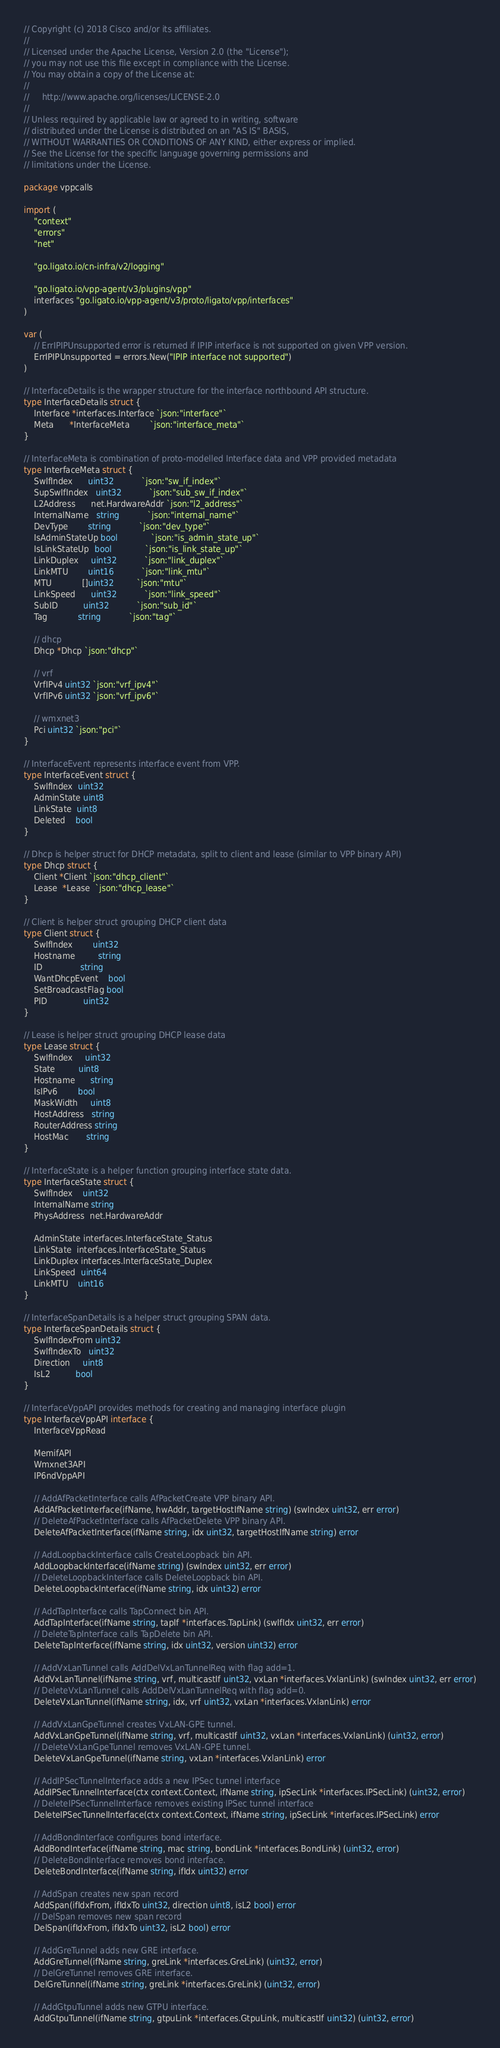<code> <loc_0><loc_0><loc_500><loc_500><_Go_>// Copyright (c) 2018 Cisco and/or its affiliates.
//
// Licensed under the Apache License, Version 2.0 (the "License");
// you may not use this file except in compliance with the License.
// You may obtain a copy of the License at:
//
//     http://www.apache.org/licenses/LICENSE-2.0
//
// Unless required by applicable law or agreed to in writing, software
// distributed under the License is distributed on an "AS IS" BASIS,
// WITHOUT WARRANTIES OR CONDITIONS OF ANY KIND, either express or implied.
// See the License for the specific language governing permissions and
// limitations under the License.

package vppcalls

import (
	"context"
	"errors"
	"net"

	"go.ligato.io/cn-infra/v2/logging"

	"go.ligato.io/vpp-agent/v3/plugins/vpp"
	interfaces "go.ligato.io/vpp-agent/v3/proto/ligato/vpp/interfaces"
)

var (
	// ErrIPIPUnsupported error is returned if IPIP interface is not supported on given VPP version.
	ErrIPIPUnsupported = errors.New("IPIP interface not supported")
)

// InterfaceDetails is the wrapper structure for the interface northbound API structure.
type InterfaceDetails struct {
	Interface *interfaces.Interface `json:"interface"`
	Meta      *InterfaceMeta        `json:"interface_meta"`
}

// InterfaceMeta is combination of proto-modelled Interface data and VPP provided metadata
type InterfaceMeta struct {
	SwIfIndex      uint32           `json:"sw_if_index"`
	SupSwIfIndex   uint32           `json:"sub_sw_if_index"`
	L2Address      net.HardwareAddr `json:"l2_address"`
	InternalName   string           `json:"internal_name"`
	DevType        string           `json:"dev_type"`
	IsAdminStateUp bool             `json:"is_admin_state_up"`
	IsLinkStateUp  bool             `json:"is_link_state_up"`
	LinkDuplex     uint32           `json:"link_duplex"`
	LinkMTU        uint16           `json:"link_mtu"`
	MTU            []uint32         `json:"mtu"`
	LinkSpeed      uint32           `json:"link_speed"`
	SubID          uint32           `json:"sub_id"`
	Tag            string           `json:"tag"`

	// dhcp
	Dhcp *Dhcp `json:"dhcp"`

	// vrf
	VrfIPv4 uint32 `json:"vrf_ipv4"`
	VrfIPv6 uint32 `json:"vrf_ipv6"`

	// wmxnet3
	Pci uint32 `json:"pci"`
}

// InterfaceEvent represents interface event from VPP.
type InterfaceEvent struct {
	SwIfIndex  uint32
	AdminState uint8
	LinkState  uint8
	Deleted    bool
}

// Dhcp is helper struct for DHCP metadata, split to client and lease (similar to VPP binary API)
type Dhcp struct {
	Client *Client `json:"dhcp_client"`
	Lease  *Lease  `json:"dhcp_lease"`
}

// Client is helper struct grouping DHCP client data
type Client struct {
	SwIfIndex        uint32
	Hostname         string
	ID               string
	WantDhcpEvent    bool
	SetBroadcastFlag bool
	PID              uint32
}

// Lease is helper struct grouping DHCP lease data
type Lease struct {
	SwIfIndex     uint32
	State         uint8
	Hostname      string
	IsIPv6        bool
	MaskWidth     uint8
	HostAddress   string
	RouterAddress string
	HostMac       string
}

// InterfaceState is a helper function grouping interface state data.
type InterfaceState struct {
	SwIfIndex    uint32
	InternalName string
	PhysAddress  net.HardwareAddr

	AdminState interfaces.InterfaceState_Status
	LinkState  interfaces.InterfaceState_Status
	LinkDuplex interfaces.InterfaceState_Duplex
	LinkSpeed  uint64
	LinkMTU    uint16
}

// InterfaceSpanDetails is a helper struct grouping SPAN data.
type InterfaceSpanDetails struct {
	SwIfIndexFrom uint32
	SwIfIndexTo   uint32
	Direction     uint8
	IsL2          bool
}

// InterfaceVppAPI provides methods for creating and managing interface plugin
type InterfaceVppAPI interface {
	InterfaceVppRead

	MemifAPI
	Wmxnet3API
	IP6ndVppAPI

	// AddAfPacketInterface calls AfPacketCreate VPP binary API.
	AddAfPacketInterface(ifName, hwAddr, targetHostIfName string) (swIndex uint32, err error)
	// DeleteAfPacketInterface calls AfPacketDelete VPP binary API.
	DeleteAfPacketInterface(ifName string, idx uint32, targetHostIfName string) error

	// AddLoopbackInterface calls CreateLoopback bin API.
	AddLoopbackInterface(ifName string) (swIndex uint32, err error)
	// DeleteLoopbackInterface calls DeleteLoopback bin API.
	DeleteLoopbackInterface(ifName string, idx uint32) error

	// AddTapInterface calls TapConnect bin API.
	AddTapInterface(ifName string, tapIf *interfaces.TapLink) (swIfIdx uint32, err error)
	// DeleteTapInterface calls TapDelete bin API.
	DeleteTapInterface(ifName string, idx uint32, version uint32) error

	// AddVxLanTunnel calls AddDelVxLanTunnelReq with flag add=1.
	AddVxLanTunnel(ifName string, vrf, multicastIf uint32, vxLan *interfaces.VxlanLink) (swIndex uint32, err error)
	// DeleteVxLanTunnel calls AddDelVxLanTunnelReq with flag add=0.
	DeleteVxLanTunnel(ifName string, idx, vrf uint32, vxLan *interfaces.VxlanLink) error

	// AddVxLanGpeTunnel creates VxLAN-GPE tunnel.
	AddVxLanGpeTunnel(ifName string, vrf, multicastIf uint32, vxLan *interfaces.VxlanLink) (uint32, error)
	// DeleteVxLanGpeTunnel removes VxLAN-GPE tunnel.
	DeleteVxLanGpeTunnel(ifName string, vxLan *interfaces.VxlanLink) error

	// AddIPSecTunnelInterface adds a new IPSec tunnel interface
	AddIPSecTunnelInterface(ctx context.Context, ifName string, ipSecLink *interfaces.IPSecLink) (uint32, error)
	// DeleteIPSecTunnelInterface removes existing IPSec tunnel interface
	DeleteIPSecTunnelInterface(ctx context.Context, ifName string, ipSecLink *interfaces.IPSecLink) error

	// AddBondInterface configures bond interface.
	AddBondInterface(ifName string, mac string, bondLink *interfaces.BondLink) (uint32, error)
	// DeleteBondInterface removes bond interface.
	DeleteBondInterface(ifName string, ifIdx uint32) error

	// AddSpan creates new span record
	AddSpan(ifIdxFrom, ifIdxTo uint32, direction uint8, isL2 bool) error
	// DelSpan removes new span record
	DelSpan(ifIdxFrom, ifIdxTo uint32, isL2 bool) error

	// AddGreTunnel adds new GRE interface.
	AddGreTunnel(ifName string, greLink *interfaces.GreLink) (uint32, error)
	// DelGreTunnel removes GRE interface.
	DelGreTunnel(ifName string, greLink *interfaces.GreLink) (uint32, error)

	// AddGtpuTunnel adds new GTPU interface.
	AddGtpuTunnel(ifName string, gtpuLink *interfaces.GtpuLink, multicastIf uint32) (uint32, error)</code> 